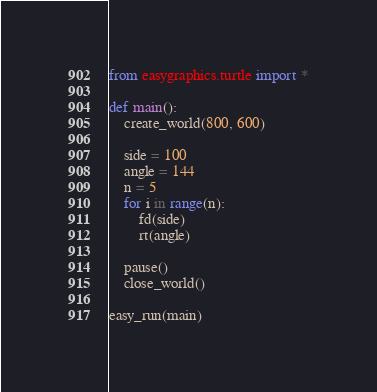Convert code to text. <code><loc_0><loc_0><loc_500><loc_500><_Python_>from easygraphics.turtle import *

def main():
    create_world(800, 600)

    side = 100
    angle = 144
    n = 5
    for i in range(n):
        fd(side)
        rt(angle)

    pause()
    close_world()

easy_run(main)</code> 